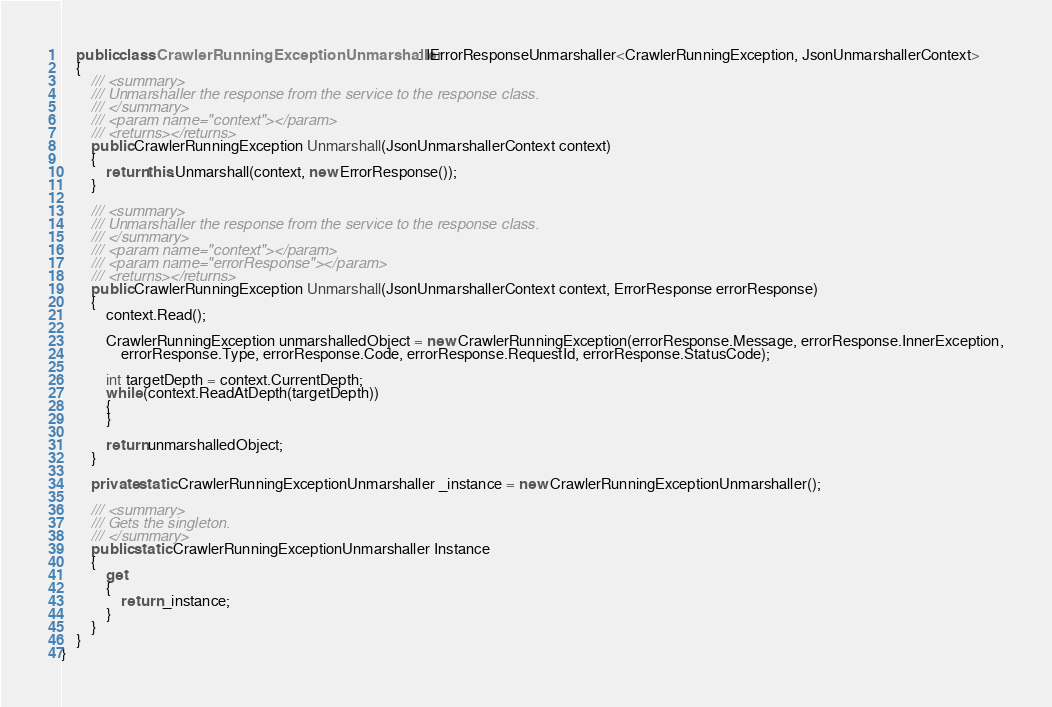Convert code to text. <code><loc_0><loc_0><loc_500><loc_500><_C#_>    public class CrawlerRunningExceptionUnmarshaller : IErrorResponseUnmarshaller<CrawlerRunningException, JsonUnmarshallerContext>
    {
        /// <summary>
        /// Unmarshaller the response from the service to the response class.
        /// </summary>  
        /// <param name="context"></param>
        /// <returns></returns>
        public CrawlerRunningException Unmarshall(JsonUnmarshallerContext context)
        {
            return this.Unmarshall(context, new ErrorResponse());
        }

        /// <summary>
        /// Unmarshaller the response from the service to the response class.
        /// </summary>  
        /// <param name="context"></param>
        /// <param name="errorResponse"></param>
        /// <returns></returns>
        public CrawlerRunningException Unmarshall(JsonUnmarshallerContext context, ErrorResponse errorResponse)
        {
            context.Read();

            CrawlerRunningException unmarshalledObject = new CrawlerRunningException(errorResponse.Message, errorResponse.InnerException,
                errorResponse.Type, errorResponse.Code, errorResponse.RequestId, errorResponse.StatusCode);
        
            int targetDepth = context.CurrentDepth;
            while (context.ReadAtDepth(targetDepth))
            {
            }
          
            return unmarshalledObject;
        }

        private static CrawlerRunningExceptionUnmarshaller _instance = new CrawlerRunningExceptionUnmarshaller();        

        /// <summary>
        /// Gets the singleton.
        /// </summary>  
        public static CrawlerRunningExceptionUnmarshaller Instance
        {
            get
            {
                return _instance;
            }
        }
    }
}</code> 